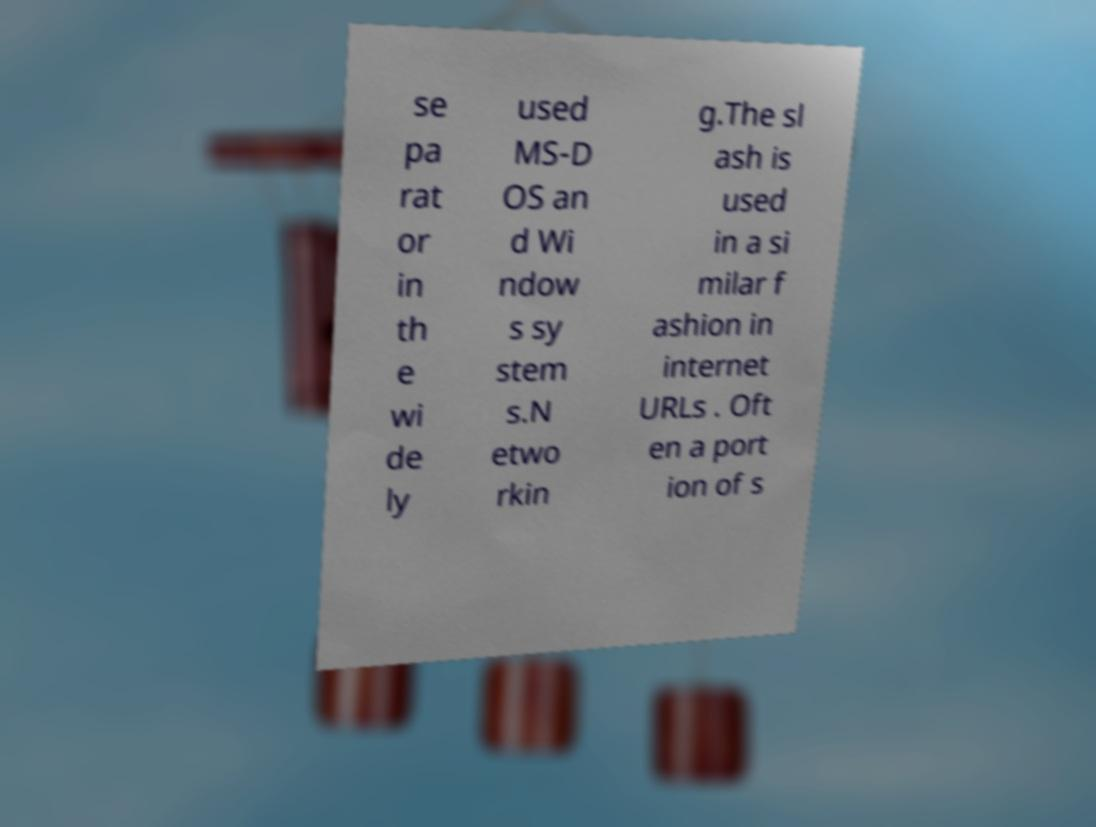There's text embedded in this image that I need extracted. Can you transcribe it verbatim? se pa rat or in th e wi de ly used MS-D OS an d Wi ndow s sy stem s.N etwo rkin g.The sl ash is used in a si milar f ashion in internet URLs . Oft en a port ion of s 